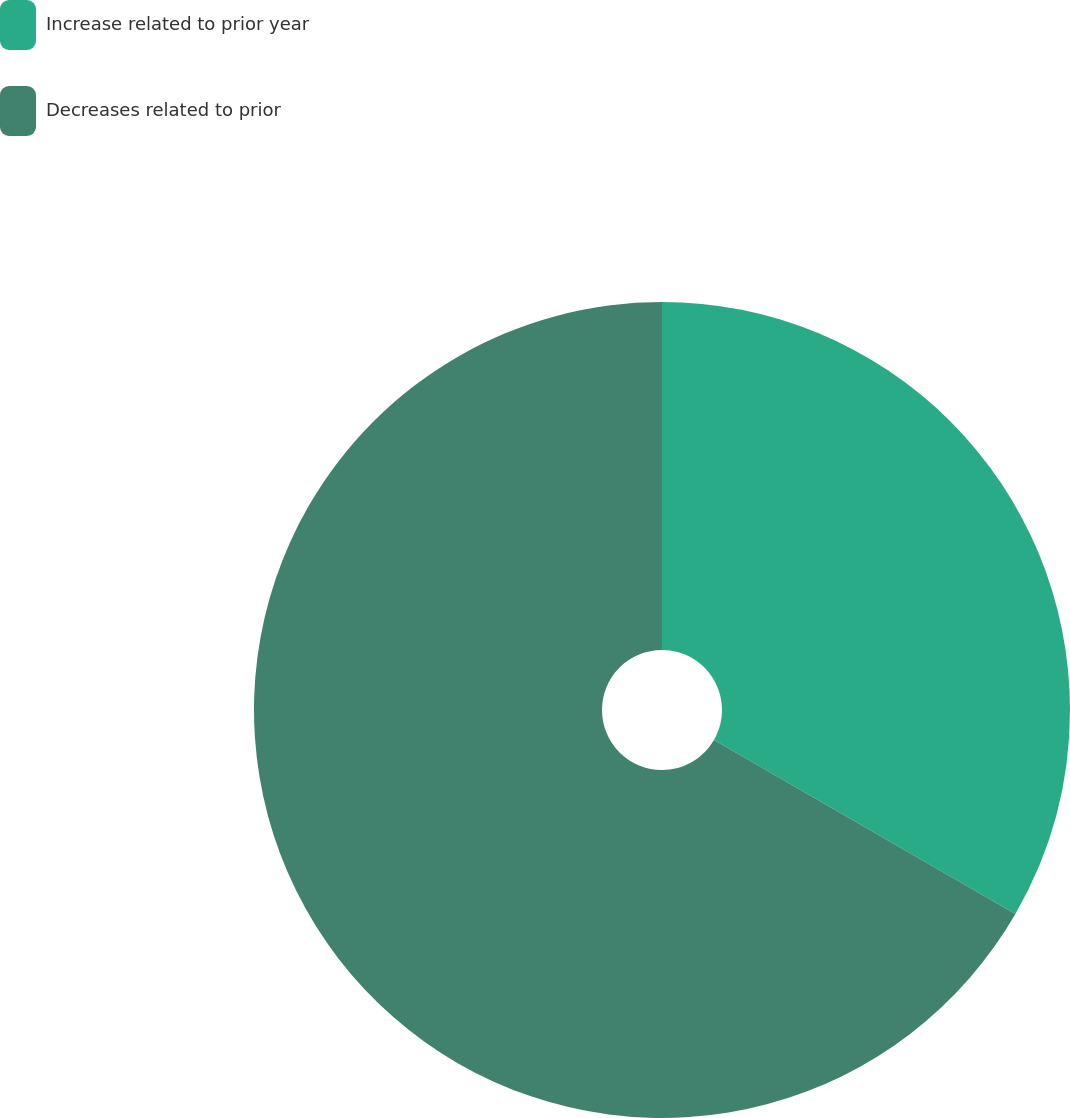Convert chart. <chart><loc_0><loc_0><loc_500><loc_500><pie_chart><fcel>Increase related to prior year<fcel>Decreases related to prior<nl><fcel>33.33%<fcel>66.67%<nl></chart> 